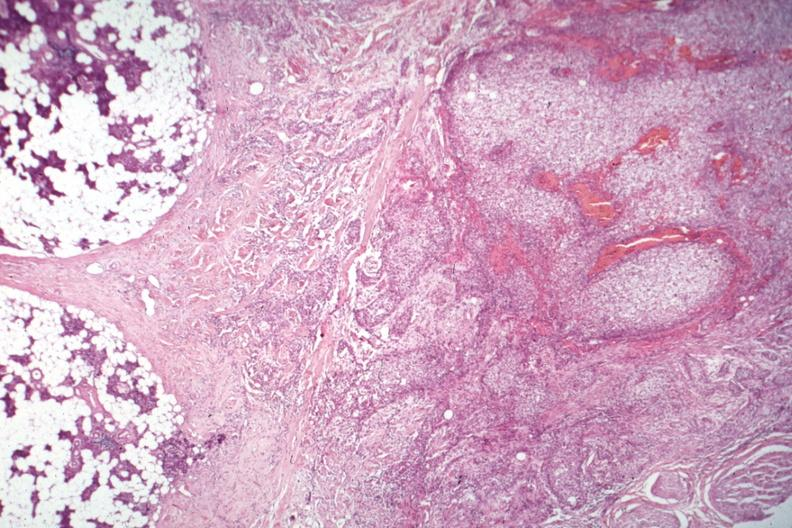s parathyroid present?
Answer the question using a single word or phrase. Yes 